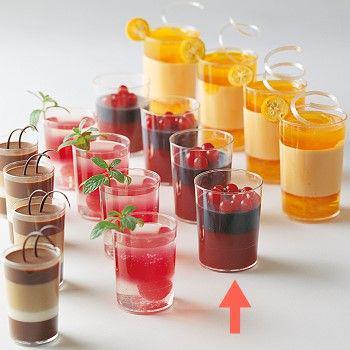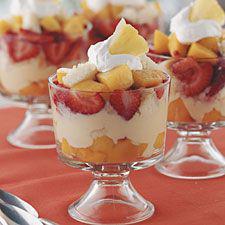The first image is the image on the left, the second image is the image on the right. Considering the images on both sides, is "there are blueberries on the top of the dessert on the right" valid? Answer yes or no. No. The first image is the image on the left, the second image is the image on the right. Analyze the images presented: Is the assertion "There are at least four different recipes in cups." valid? Answer yes or no. Yes. 